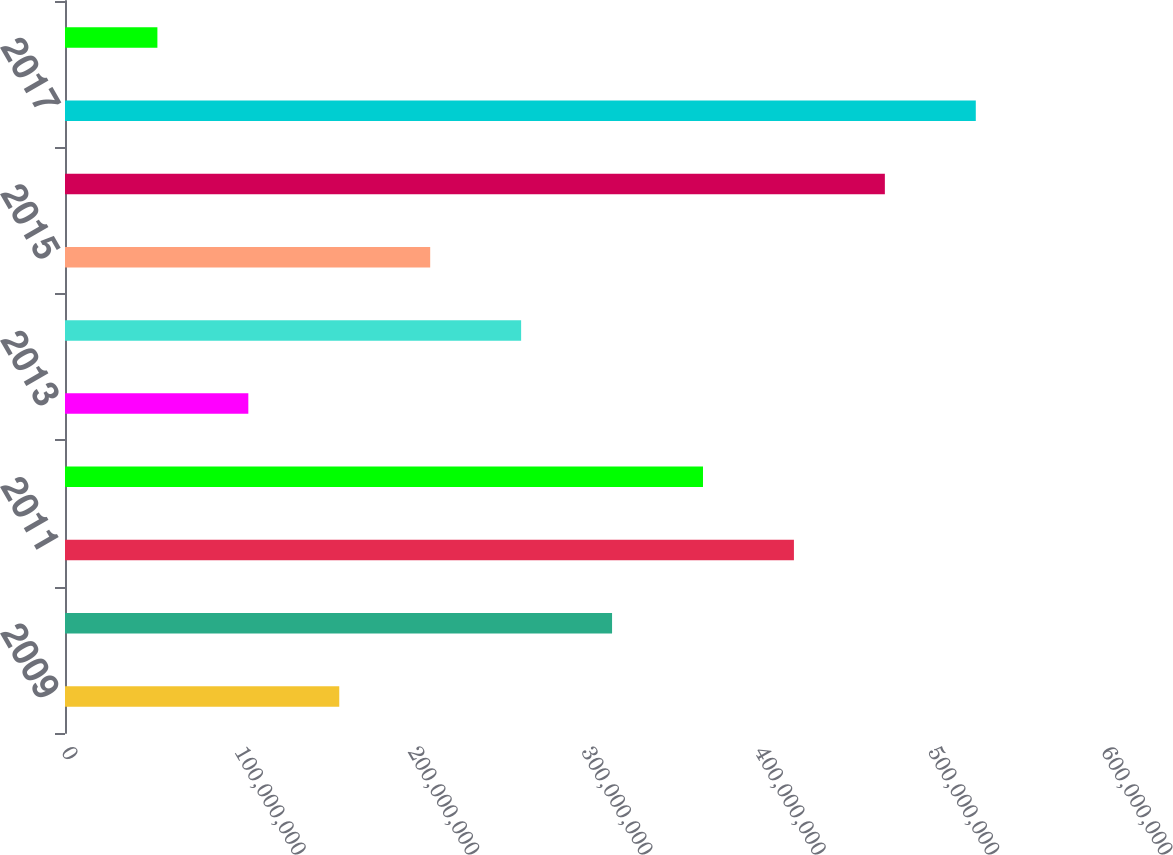Convert chart. <chart><loc_0><loc_0><loc_500><loc_500><bar_chart><fcel>2009<fcel>2010<fcel>2011<fcel>2012<fcel>2013<fcel>2014<fcel>2015<fcel>2016<fcel>2017<fcel>2018<nl><fcel>1.58228e+08<fcel>3.15612e+08<fcel>4.20535e+08<fcel>3.68073e+08<fcel>1.05766e+08<fcel>2.6315e+08<fcel>2.10689e+08<fcel>4.72996e+08<fcel>5.25458e+08<fcel>5.33047e+07<nl></chart> 